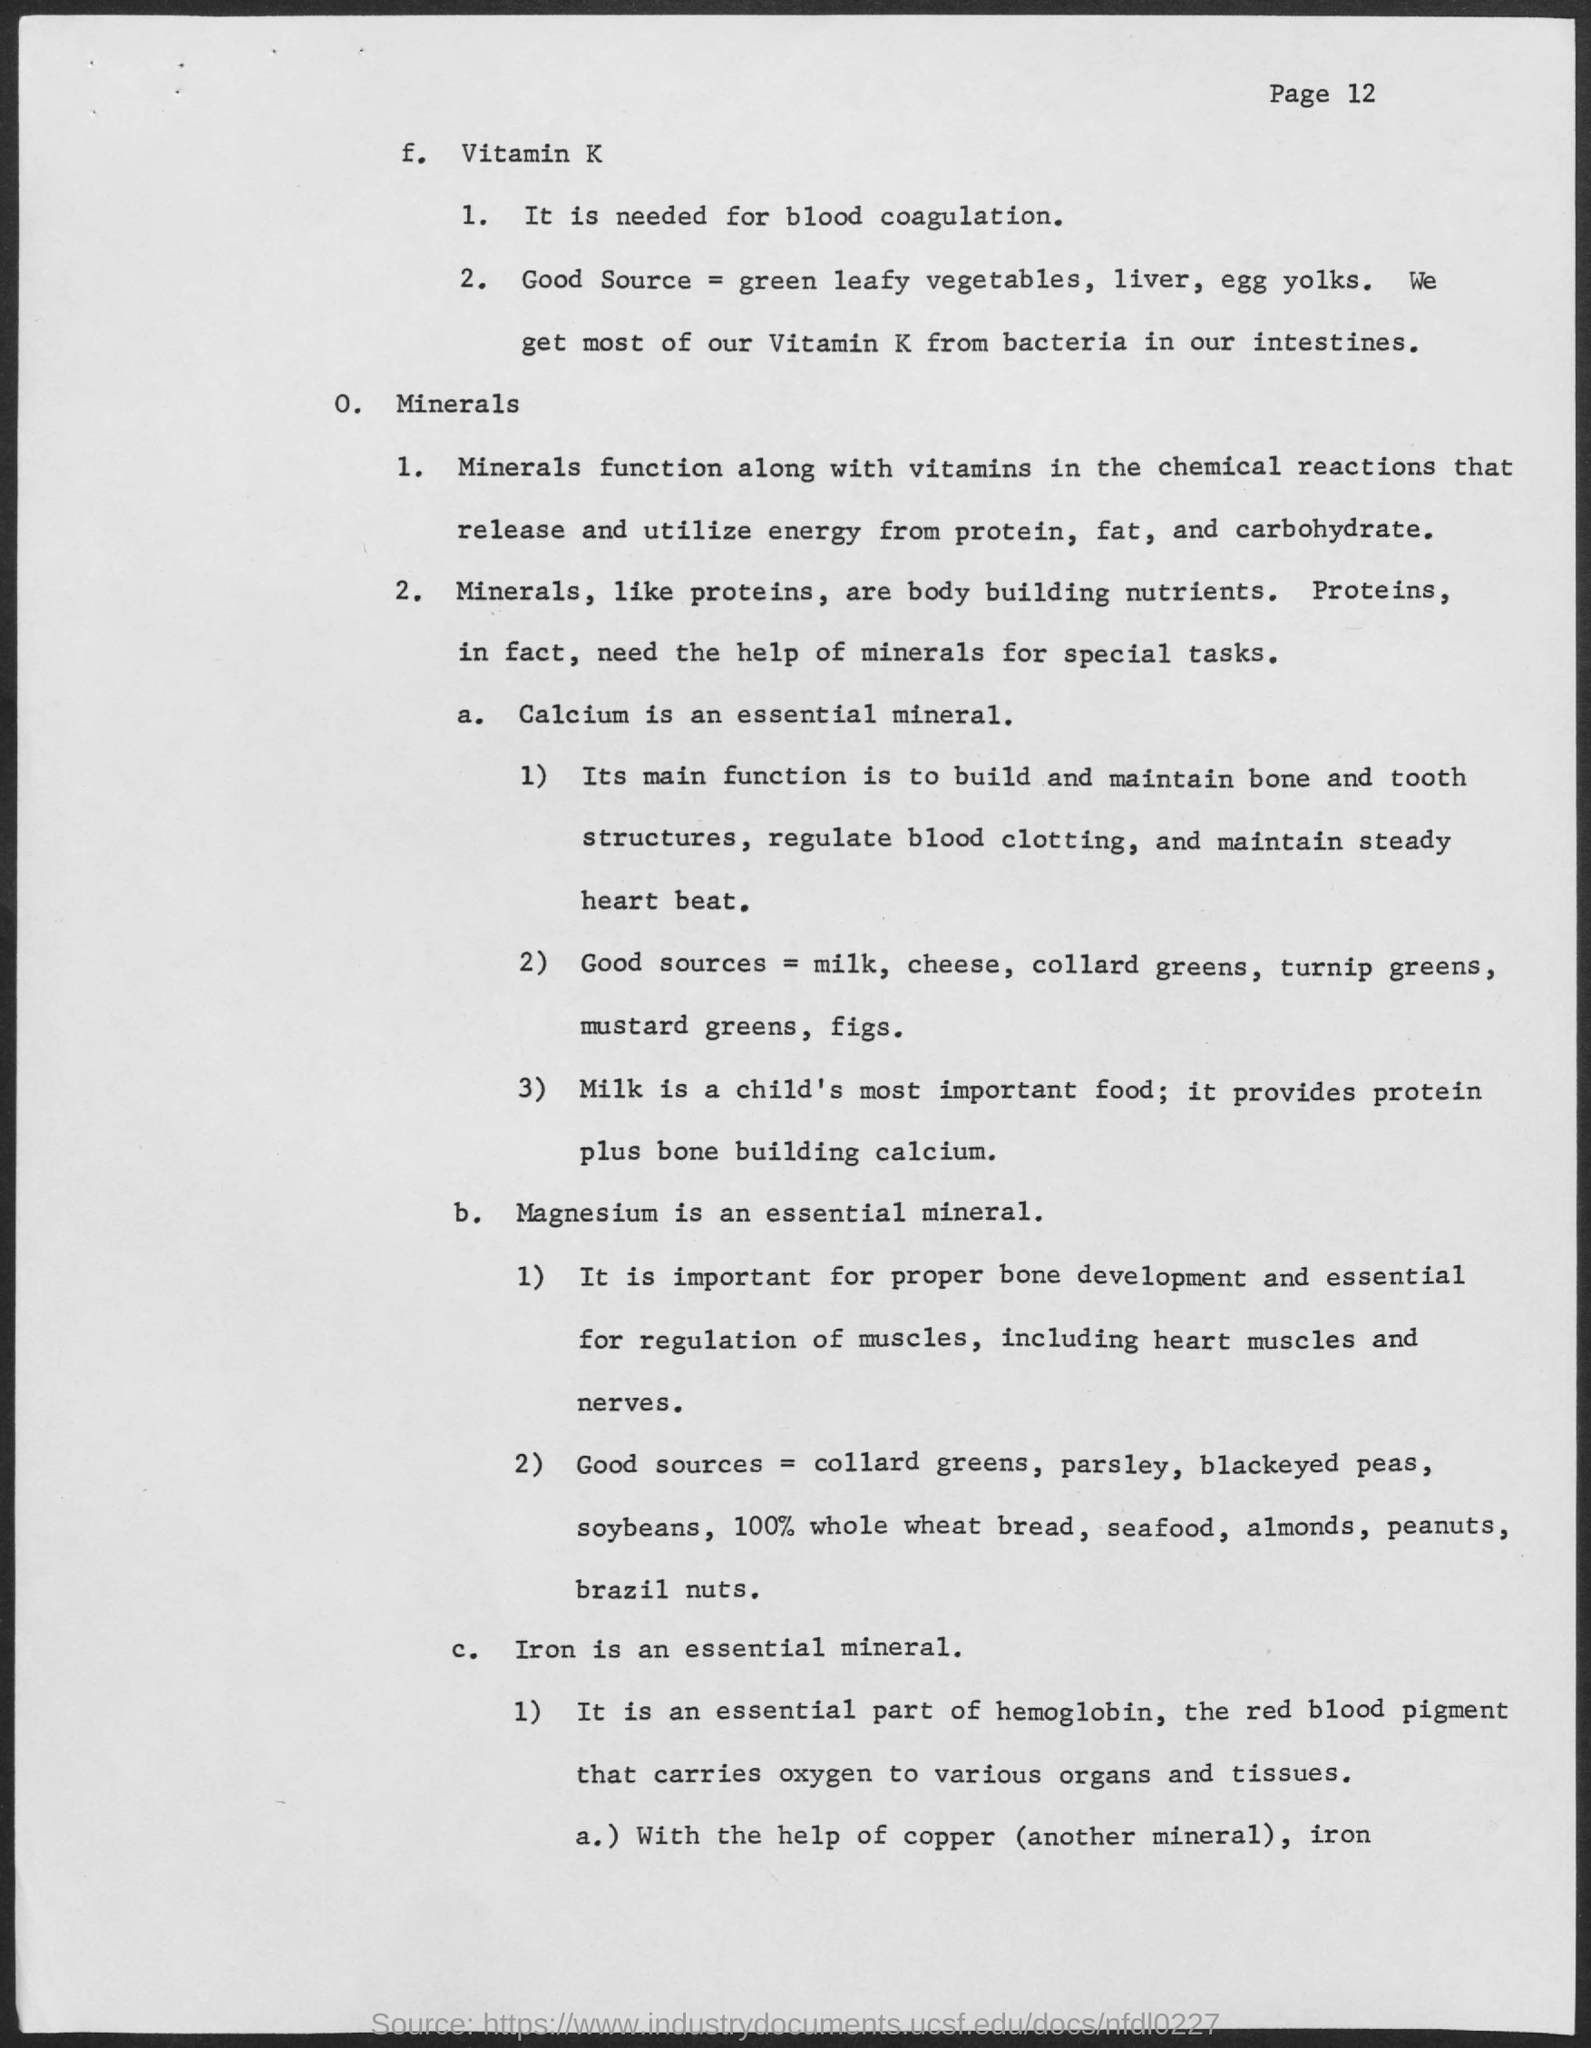What is the mineral needed for steady  heart beat?
Keep it short and to the point. Calcium. What is the main source of calcium for child?
Provide a succinct answer. Milk. What is the mineral mainly found in hemoglobin?
Give a very brief answer. Iron. What is the mineral needed for proper bone development?
Provide a short and direct response. Magnesium. 